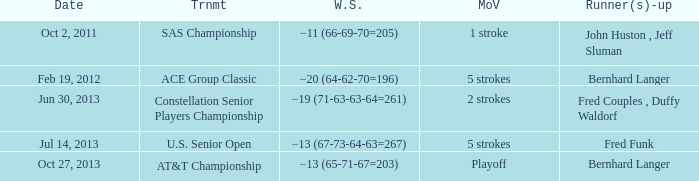Which date features a 5-stroke margin of victory and a winning score of -13 (67-73-64-63=267)? Jul 14, 2013. 